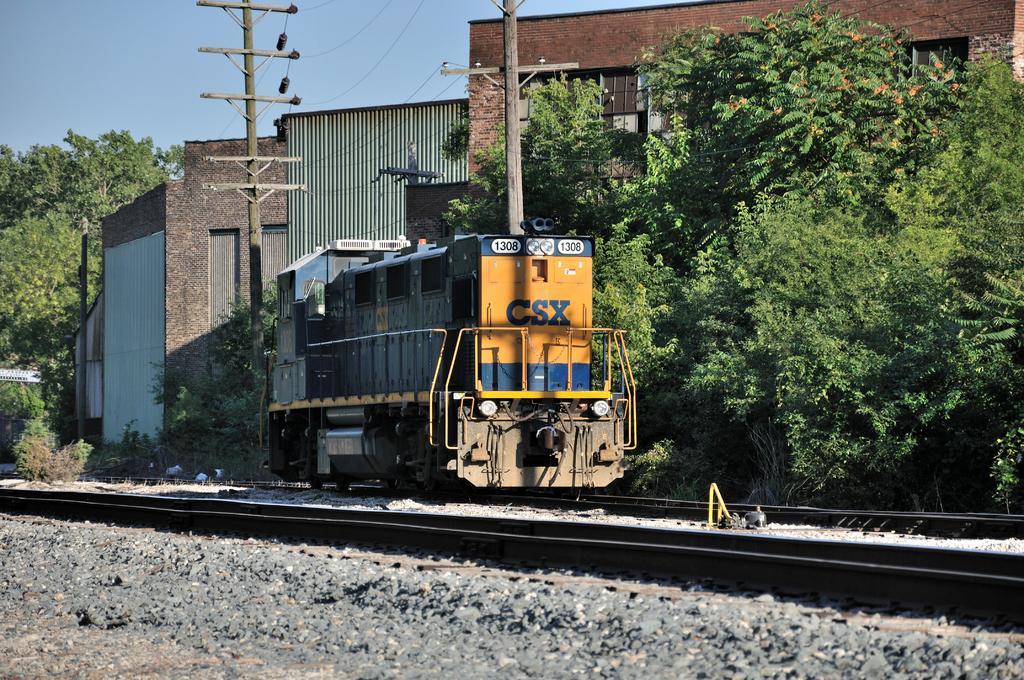In one or two sentences, can you explain what this image depicts? In this image there is a train on the railway track. At the bottom of the image there are stones. In the background of the image there are trees, buildings, electrical poles with cables. At the top of the image there is sky. 